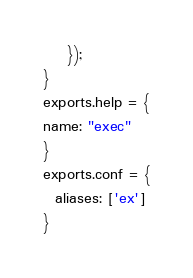Convert code to text. <code><loc_0><loc_0><loc_500><loc_500><_JavaScript_>    });
}
exports.help = {
name: "exec"
}
exports.conf = {
  aliases: ['ex']
}</code> 